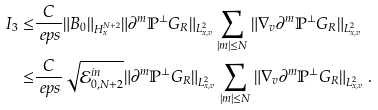<formula> <loc_0><loc_0><loc_500><loc_500>I _ { 3 } \leq & \frac { C } { \ e p s } \| B _ { 0 } \| _ { H ^ { N + 2 } _ { x } } \| \partial ^ { m } \mathbb { P } ^ { \perp } G _ { R } \| _ { L ^ { 2 } _ { x , v } } \sum _ { | m | \leq N } \| \nabla _ { v } \partial ^ { m } \mathbb { P } ^ { \perp } G _ { R } \| _ { L ^ { 2 } _ { x , v } } \\ \leq & \frac { C } { \ e p s } \sqrt { \mathcal { E } ^ { i n } _ { 0 , N + 2 } } \| \partial ^ { m } \mathbb { P } ^ { \perp } G _ { R } \| _ { L ^ { 2 } _ { x , v } } \sum _ { | m | \leq N } \| \nabla _ { v } \partial ^ { m } \mathbb { P } ^ { \perp } G _ { R } \| _ { L ^ { 2 } _ { x , v } } \, .</formula> 